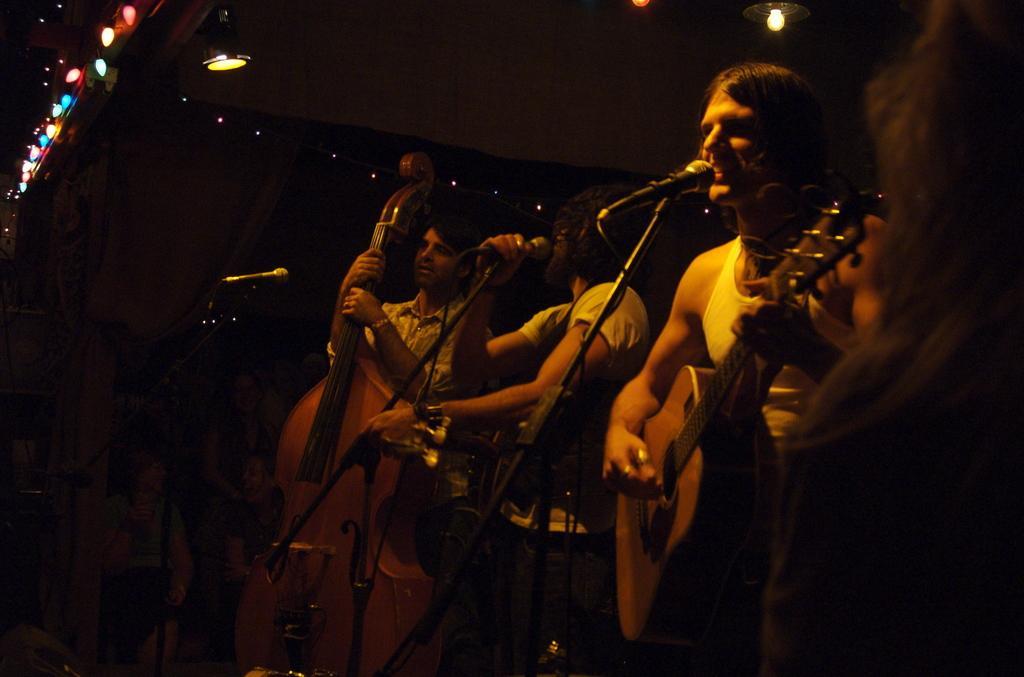How would you summarize this image in a sentence or two? This picture shows a man playing a guitar and singing with the help of a microphone and other Man Standing and singing holding a microphone in his hand and we see Third Man playing violin and we see a microphone and front of him and we see couple of lights 